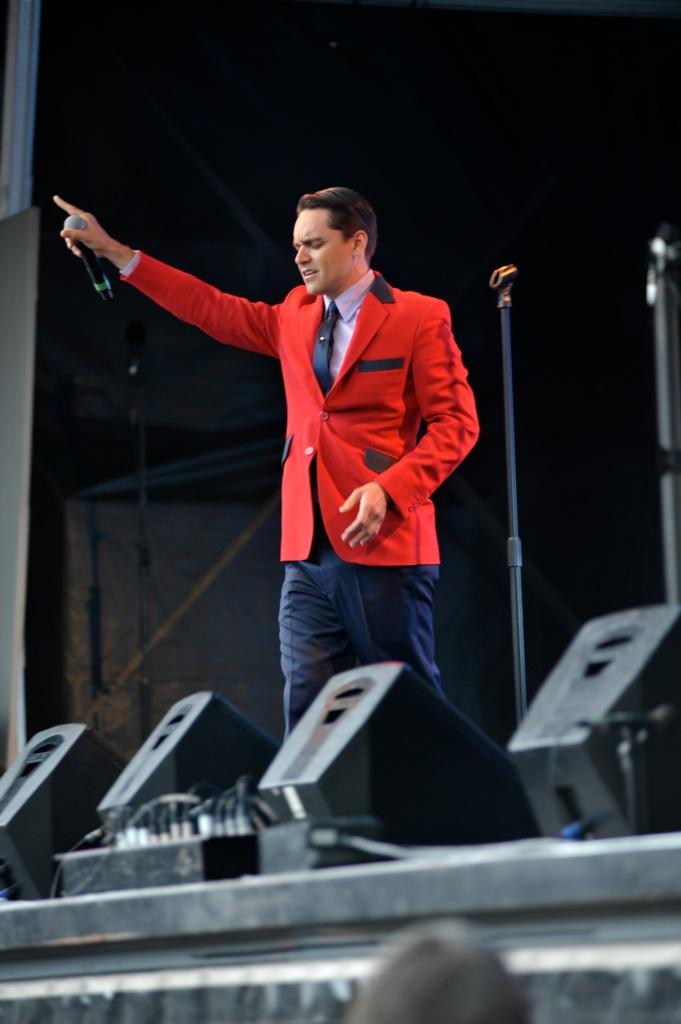Who is the main subject in the image? There is a man in the image. What is the man holding in his hand? The man is holding a mic in his hand. What can be seen in the background of the image? There is a mic stand in the background of the image. What type of lighting is visible in the image? There are lights visible at the bottom of the image. What type of earth can be seen in the image? There is no reference to earth in the image. 